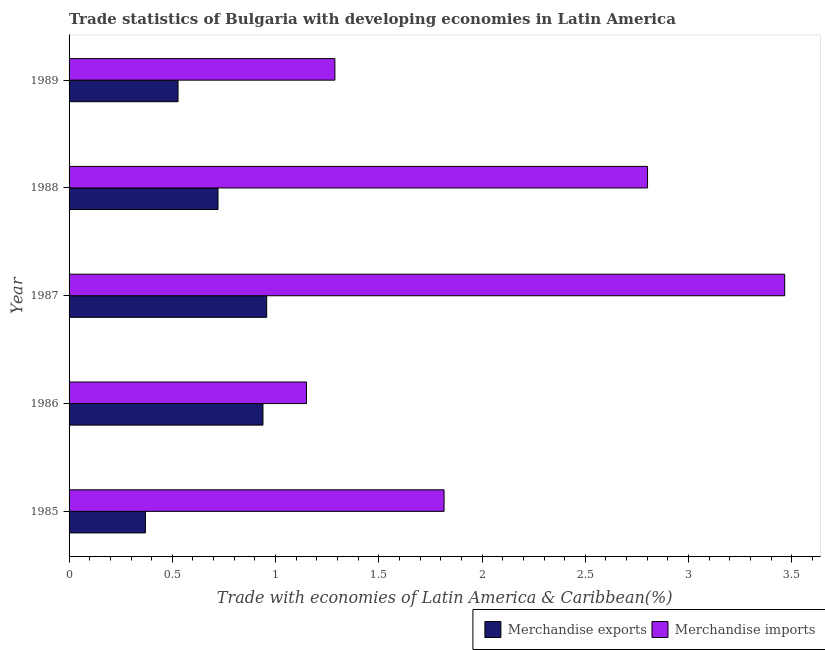Are the number of bars per tick equal to the number of legend labels?
Offer a very short reply. Yes. How many bars are there on the 1st tick from the top?
Make the answer very short. 2. How many bars are there on the 1st tick from the bottom?
Offer a very short reply. 2. What is the label of the 2nd group of bars from the top?
Your answer should be very brief. 1988. What is the merchandise exports in 1988?
Give a very brief answer. 0.72. Across all years, what is the maximum merchandise imports?
Give a very brief answer. 3.47. Across all years, what is the minimum merchandise imports?
Provide a short and direct response. 1.15. What is the total merchandise imports in the graph?
Make the answer very short. 10.52. What is the difference between the merchandise imports in 1986 and that in 1987?
Provide a succinct answer. -2.32. What is the difference between the merchandise imports in 1985 and the merchandise exports in 1988?
Keep it short and to the point. 1.09. What is the average merchandise imports per year?
Offer a terse response. 2.1. In the year 1988, what is the difference between the merchandise exports and merchandise imports?
Provide a short and direct response. -2.08. What is the ratio of the merchandise exports in 1987 to that in 1989?
Give a very brief answer. 1.81. Is the merchandise imports in 1985 less than that in 1989?
Provide a succinct answer. No. What is the difference between the highest and the second highest merchandise exports?
Make the answer very short. 0.02. What is the difference between the highest and the lowest merchandise imports?
Provide a short and direct response. 2.32. In how many years, is the merchandise exports greater than the average merchandise exports taken over all years?
Keep it short and to the point. 3. How many bars are there?
Provide a succinct answer. 10. What is the difference between two consecutive major ticks on the X-axis?
Provide a short and direct response. 0.5. Does the graph contain any zero values?
Make the answer very short. No. How many legend labels are there?
Give a very brief answer. 2. How are the legend labels stacked?
Ensure brevity in your answer.  Horizontal. What is the title of the graph?
Provide a short and direct response. Trade statistics of Bulgaria with developing economies in Latin America. What is the label or title of the X-axis?
Your answer should be compact. Trade with economies of Latin America & Caribbean(%). What is the Trade with economies of Latin America & Caribbean(%) in Merchandise exports in 1985?
Provide a succinct answer. 0.37. What is the Trade with economies of Latin America & Caribbean(%) of Merchandise imports in 1985?
Your answer should be very brief. 1.82. What is the Trade with economies of Latin America & Caribbean(%) of Merchandise exports in 1986?
Offer a very short reply. 0.94. What is the Trade with economies of Latin America & Caribbean(%) in Merchandise imports in 1986?
Offer a very short reply. 1.15. What is the Trade with economies of Latin America & Caribbean(%) in Merchandise exports in 1987?
Give a very brief answer. 0.96. What is the Trade with economies of Latin America & Caribbean(%) in Merchandise imports in 1987?
Make the answer very short. 3.47. What is the Trade with economies of Latin America & Caribbean(%) in Merchandise exports in 1988?
Keep it short and to the point. 0.72. What is the Trade with economies of Latin America & Caribbean(%) of Merchandise imports in 1988?
Your answer should be compact. 2.8. What is the Trade with economies of Latin America & Caribbean(%) in Merchandise exports in 1989?
Keep it short and to the point. 0.53. What is the Trade with economies of Latin America & Caribbean(%) of Merchandise imports in 1989?
Offer a terse response. 1.29. Across all years, what is the maximum Trade with economies of Latin America & Caribbean(%) of Merchandise exports?
Give a very brief answer. 0.96. Across all years, what is the maximum Trade with economies of Latin America & Caribbean(%) in Merchandise imports?
Your response must be concise. 3.47. Across all years, what is the minimum Trade with economies of Latin America & Caribbean(%) in Merchandise exports?
Offer a very short reply. 0.37. Across all years, what is the minimum Trade with economies of Latin America & Caribbean(%) of Merchandise imports?
Give a very brief answer. 1.15. What is the total Trade with economies of Latin America & Caribbean(%) of Merchandise exports in the graph?
Ensure brevity in your answer.  3.51. What is the total Trade with economies of Latin America & Caribbean(%) in Merchandise imports in the graph?
Give a very brief answer. 10.52. What is the difference between the Trade with economies of Latin America & Caribbean(%) in Merchandise exports in 1985 and that in 1986?
Offer a terse response. -0.57. What is the difference between the Trade with economies of Latin America & Caribbean(%) of Merchandise imports in 1985 and that in 1986?
Keep it short and to the point. 0.67. What is the difference between the Trade with economies of Latin America & Caribbean(%) of Merchandise exports in 1985 and that in 1987?
Make the answer very short. -0.59. What is the difference between the Trade with economies of Latin America & Caribbean(%) of Merchandise imports in 1985 and that in 1987?
Your answer should be very brief. -1.65. What is the difference between the Trade with economies of Latin America & Caribbean(%) in Merchandise exports in 1985 and that in 1988?
Provide a short and direct response. -0.35. What is the difference between the Trade with economies of Latin America & Caribbean(%) of Merchandise imports in 1985 and that in 1988?
Your answer should be very brief. -0.99. What is the difference between the Trade with economies of Latin America & Caribbean(%) of Merchandise exports in 1985 and that in 1989?
Offer a very short reply. -0.16. What is the difference between the Trade with economies of Latin America & Caribbean(%) in Merchandise imports in 1985 and that in 1989?
Provide a succinct answer. 0.53. What is the difference between the Trade with economies of Latin America & Caribbean(%) in Merchandise exports in 1986 and that in 1987?
Your response must be concise. -0.02. What is the difference between the Trade with economies of Latin America & Caribbean(%) of Merchandise imports in 1986 and that in 1987?
Your answer should be very brief. -2.32. What is the difference between the Trade with economies of Latin America & Caribbean(%) in Merchandise exports in 1986 and that in 1988?
Ensure brevity in your answer.  0.22. What is the difference between the Trade with economies of Latin America & Caribbean(%) in Merchandise imports in 1986 and that in 1988?
Your response must be concise. -1.65. What is the difference between the Trade with economies of Latin America & Caribbean(%) in Merchandise exports in 1986 and that in 1989?
Ensure brevity in your answer.  0.41. What is the difference between the Trade with economies of Latin America & Caribbean(%) in Merchandise imports in 1986 and that in 1989?
Provide a short and direct response. -0.14. What is the difference between the Trade with economies of Latin America & Caribbean(%) of Merchandise exports in 1987 and that in 1988?
Your answer should be very brief. 0.24. What is the difference between the Trade with economies of Latin America & Caribbean(%) in Merchandise imports in 1987 and that in 1988?
Your answer should be very brief. 0.66. What is the difference between the Trade with economies of Latin America & Caribbean(%) of Merchandise exports in 1987 and that in 1989?
Your response must be concise. 0.43. What is the difference between the Trade with economies of Latin America & Caribbean(%) in Merchandise imports in 1987 and that in 1989?
Offer a terse response. 2.18. What is the difference between the Trade with economies of Latin America & Caribbean(%) in Merchandise exports in 1988 and that in 1989?
Provide a succinct answer. 0.19. What is the difference between the Trade with economies of Latin America & Caribbean(%) of Merchandise imports in 1988 and that in 1989?
Offer a very short reply. 1.51. What is the difference between the Trade with economies of Latin America & Caribbean(%) of Merchandise exports in 1985 and the Trade with economies of Latin America & Caribbean(%) of Merchandise imports in 1986?
Provide a short and direct response. -0.78. What is the difference between the Trade with economies of Latin America & Caribbean(%) of Merchandise exports in 1985 and the Trade with economies of Latin America & Caribbean(%) of Merchandise imports in 1987?
Make the answer very short. -3.1. What is the difference between the Trade with economies of Latin America & Caribbean(%) in Merchandise exports in 1985 and the Trade with economies of Latin America & Caribbean(%) in Merchandise imports in 1988?
Offer a terse response. -2.43. What is the difference between the Trade with economies of Latin America & Caribbean(%) of Merchandise exports in 1985 and the Trade with economies of Latin America & Caribbean(%) of Merchandise imports in 1989?
Provide a succinct answer. -0.92. What is the difference between the Trade with economies of Latin America & Caribbean(%) in Merchandise exports in 1986 and the Trade with economies of Latin America & Caribbean(%) in Merchandise imports in 1987?
Ensure brevity in your answer.  -2.53. What is the difference between the Trade with economies of Latin America & Caribbean(%) of Merchandise exports in 1986 and the Trade with economies of Latin America & Caribbean(%) of Merchandise imports in 1988?
Make the answer very short. -1.86. What is the difference between the Trade with economies of Latin America & Caribbean(%) in Merchandise exports in 1986 and the Trade with economies of Latin America & Caribbean(%) in Merchandise imports in 1989?
Make the answer very short. -0.35. What is the difference between the Trade with economies of Latin America & Caribbean(%) in Merchandise exports in 1987 and the Trade with economies of Latin America & Caribbean(%) in Merchandise imports in 1988?
Provide a succinct answer. -1.84. What is the difference between the Trade with economies of Latin America & Caribbean(%) in Merchandise exports in 1987 and the Trade with economies of Latin America & Caribbean(%) in Merchandise imports in 1989?
Your answer should be very brief. -0.33. What is the difference between the Trade with economies of Latin America & Caribbean(%) of Merchandise exports in 1988 and the Trade with economies of Latin America & Caribbean(%) of Merchandise imports in 1989?
Ensure brevity in your answer.  -0.57. What is the average Trade with economies of Latin America & Caribbean(%) in Merchandise exports per year?
Provide a short and direct response. 0.7. What is the average Trade with economies of Latin America & Caribbean(%) of Merchandise imports per year?
Offer a very short reply. 2.1. In the year 1985, what is the difference between the Trade with economies of Latin America & Caribbean(%) of Merchandise exports and Trade with economies of Latin America & Caribbean(%) of Merchandise imports?
Provide a succinct answer. -1.45. In the year 1986, what is the difference between the Trade with economies of Latin America & Caribbean(%) of Merchandise exports and Trade with economies of Latin America & Caribbean(%) of Merchandise imports?
Give a very brief answer. -0.21. In the year 1987, what is the difference between the Trade with economies of Latin America & Caribbean(%) of Merchandise exports and Trade with economies of Latin America & Caribbean(%) of Merchandise imports?
Provide a short and direct response. -2.51. In the year 1988, what is the difference between the Trade with economies of Latin America & Caribbean(%) of Merchandise exports and Trade with economies of Latin America & Caribbean(%) of Merchandise imports?
Your answer should be compact. -2.08. In the year 1989, what is the difference between the Trade with economies of Latin America & Caribbean(%) in Merchandise exports and Trade with economies of Latin America & Caribbean(%) in Merchandise imports?
Keep it short and to the point. -0.76. What is the ratio of the Trade with economies of Latin America & Caribbean(%) of Merchandise exports in 1985 to that in 1986?
Make the answer very short. 0.39. What is the ratio of the Trade with economies of Latin America & Caribbean(%) of Merchandise imports in 1985 to that in 1986?
Ensure brevity in your answer.  1.58. What is the ratio of the Trade with economies of Latin America & Caribbean(%) in Merchandise exports in 1985 to that in 1987?
Provide a succinct answer. 0.39. What is the ratio of the Trade with economies of Latin America & Caribbean(%) of Merchandise imports in 1985 to that in 1987?
Give a very brief answer. 0.52. What is the ratio of the Trade with economies of Latin America & Caribbean(%) of Merchandise exports in 1985 to that in 1988?
Your answer should be compact. 0.51. What is the ratio of the Trade with economies of Latin America & Caribbean(%) of Merchandise imports in 1985 to that in 1988?
Offer a very short reply. 0.65. What is the ratio of the Trade with economies of Latin America & Caribbean(%) in Merchandise exports in 1985 to that in 1989?
Provide a succinct answer. 0.7. What is the ratio of the Trade with economies of Latin America & Caribbean(%) of Merchandise imports in 1985 to that in 1989?
Offer a terse response. 1.41. What is the ratio of the Trade with economies of Latin America & Caribbean(%) of Merchandise exports in 1986 to that in 1987?
Your answer should be compact. 0.98. What is the ratio of the Trade with economies of Latin America & Caribbean(%) in Merchandise imports in 1986 to that in 1987?
Your response must be concise. 0.33. What is the ratio of the Trade with economies of Latin America & Caribbean(%) in Merchandise exports in 1986 to that in 1988?
Your response must be concise. 1.3. What is the ratio of the Trade with economies of Latin America & Caribbean(%) in Merchandise imports in 1986 to that in 1988?
Provide a succinct answer. 0.41. What is the ratio of the Trade with economies of Latin America & Caribbean(%) of Merchandise exports in 1986 to that in 1989?
Your answer should be very brief. 1.78. What is the ratio of the Trade with economies of Latin America & Caribbean(%) in Merchandise imports in 1986 to that in 1989?
Give a very brief answer. 0.89. What is the ratio of the Trade with economies of Latin America & Caribbean(%) of Merchandise exports in 1987 to that in 1988?
Offer a very short reply. 1.33. What is the ratio of the Trade with economies of Latin America & Caribbean(%) in Merchandise imports in 1987 to that in 1988?
Offer a very short reply. 1.24. What is the ratio of the Trade with economies of Latin America & Caribbean(%) in Merchandise exports in 1987 to that in 1989?
Your answer should be compact. 1.81. What is the ratio of the Trade with economies of Latin America & Caribbean(%) in Merchandise imports in 1987 to that in 1989?
Provide a short and direct response. 2.69. What is the ratio of the Trade with economies of Latin America & Caribbean(%) of Merchandise exports in 1988 to that in 1989?
Make the answer very short. 1.37. What is the ratio of the Trade with economies of Latin America & Caribbean(%) in Merchandise imports in 1988 to that in 1989?
Provide a short and direct response. 2.18. What is the difference between the highest and the second highest Trade with economies of Latin America & Caribbean(%) of Merchandise exports?
Give a very brief answer. 0.02. What is the difference between the highest and the second highest Trade with economies of Latin America & Caribbean(%) in Merchandise imports?
Your answer should be compact. 0.66. What is the difference between the highest and the lowest Trade with economies of Latin America & Caribbean(%) of Merchandise exports?
Your response must be concise. 0.59. What is the difference between the highest and the lowest Trade with economies of Latin America & Caribbean(%) of Merchandise imports?
Offer a very short reply. 2.32. 